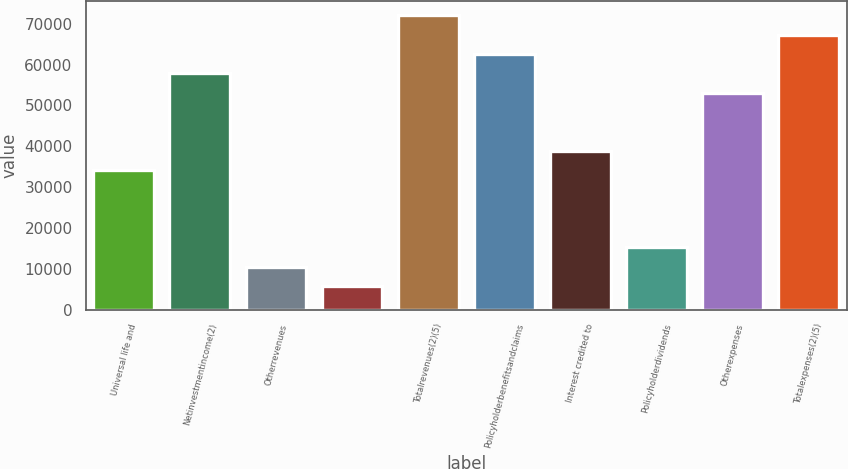Convert chart to OTSL. <chart><loc_0><loc_0><loc_500><loc_500><bar_chart><fcel>Universal life and<fcel>Netinvestmentincome(2)<fcel>Otherrevenues<fcel>Unnamed: 3<fcel>Totalrevenues(2)(5)<fcel>Policyholderbenefitsandclaims<fcel>Interest credited to<fcel>Policyholderdividends<fcel>Otherexpenses<fcel>Totalexpenses(2)(5)<nl><fcel>34212<fcel>57852<fcel>10572<fcel>5844<fcel>72036<fcel>62580<fcel>38940<fcel>15300<fcel>53124<fcel>67308<nl></chart> 